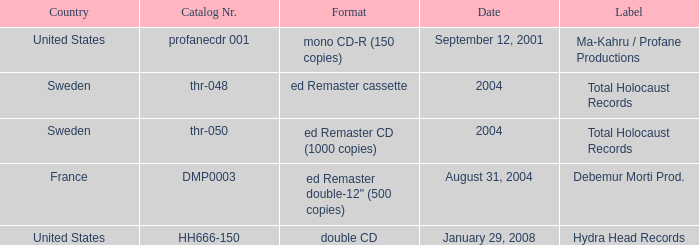Which country has the catalog nr of thr-048 in 2004? Sweden. 